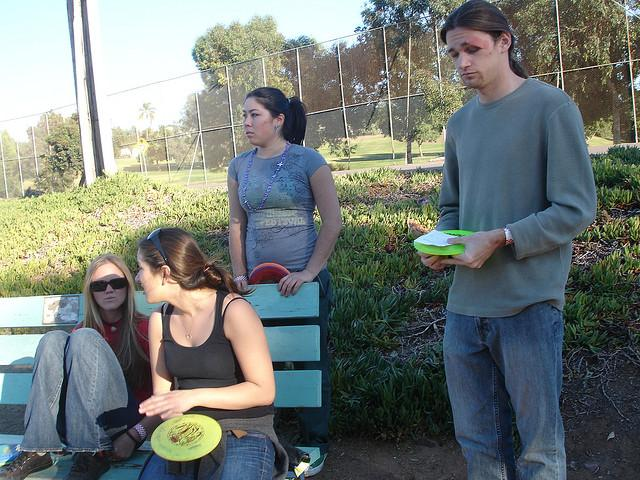What are they doing?

Choices:
A) awaiting bus
B) eating lunch
C) resting
D) seeking food eating lunch 